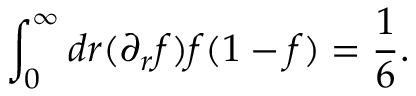Convert formula to latex. <formula><loc_0><loc_0><loc_500><loc_500>\int _ { 0 } ^ { \infty } d r ( \partial _ { r } f ) f ( 1 - f ) = \frac { 1 } { 6 } .</formula> 